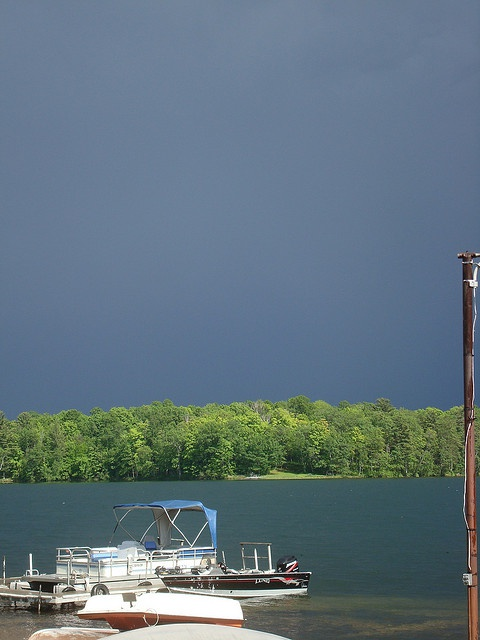Describe the objects in this image and their specific colors. I can see boat in gray, white, purple, and darkgray tones and boat in gray, white, maroon, and brown tones in this image. 